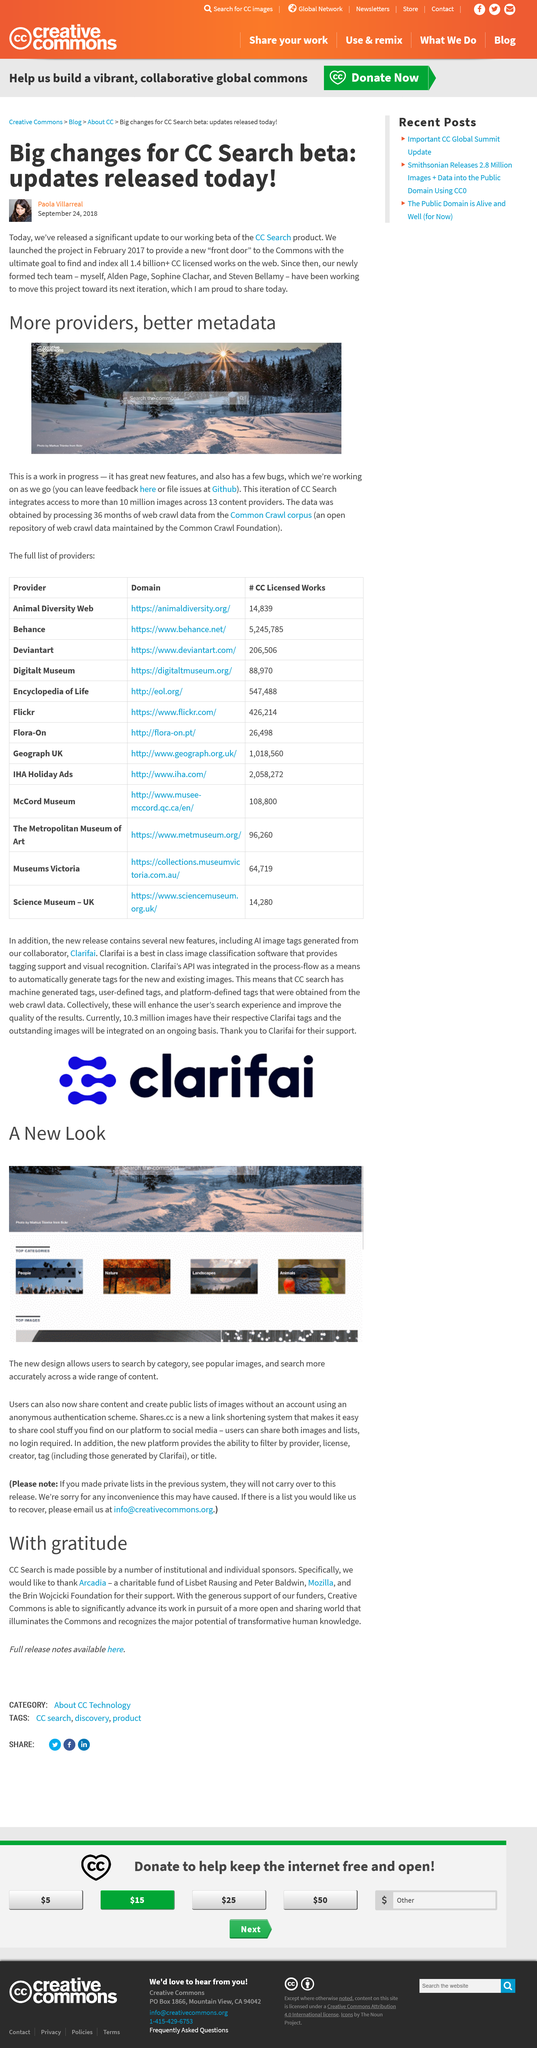Identify some key points in this picture. There are 13 content providers involved in the search engine. The title of this text is 'What is the title? More providers, better metadata..' The CC Search beta was released on September 24, 2018, and it underwent significant changes. The CC Search project was launched in February 2017. The Common Crawl Foundation is the name of a foundation. 